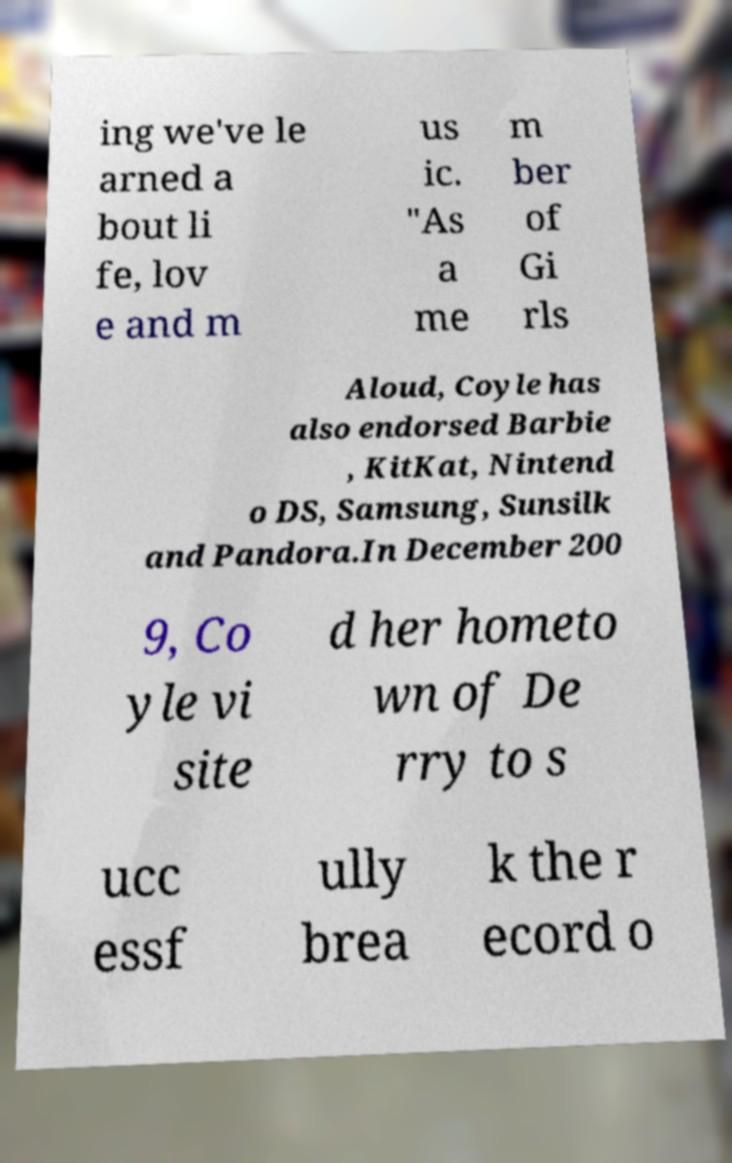Could you assist in decoding the text presented in this image and type it out clearly? ing we've le arned a bout li fe, lov e and m us ic. "As a me m ber of Gi rls Aloud, Coyle has also endorsed Barbie , KitKat, Nintend o DS, Samsung, Sunsilk and Pandora.In December 200 9, Co yle vi site d her hometo wn of De rry to s ucc essf ully brea k the r ecord o 